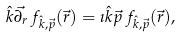Convert formula to latex. <formula><loc_0><loc_0><loc_500><loc_500>\hat { k } \vec { \partial _ { r } } \, f _ { \hat { k } , \vec { p } } ( \vec { r } ) = \imath \hat { k } \vec { p } \, f _ { \hat { k } , \vec { p } } ( \vec { r } ) ,</formula> 